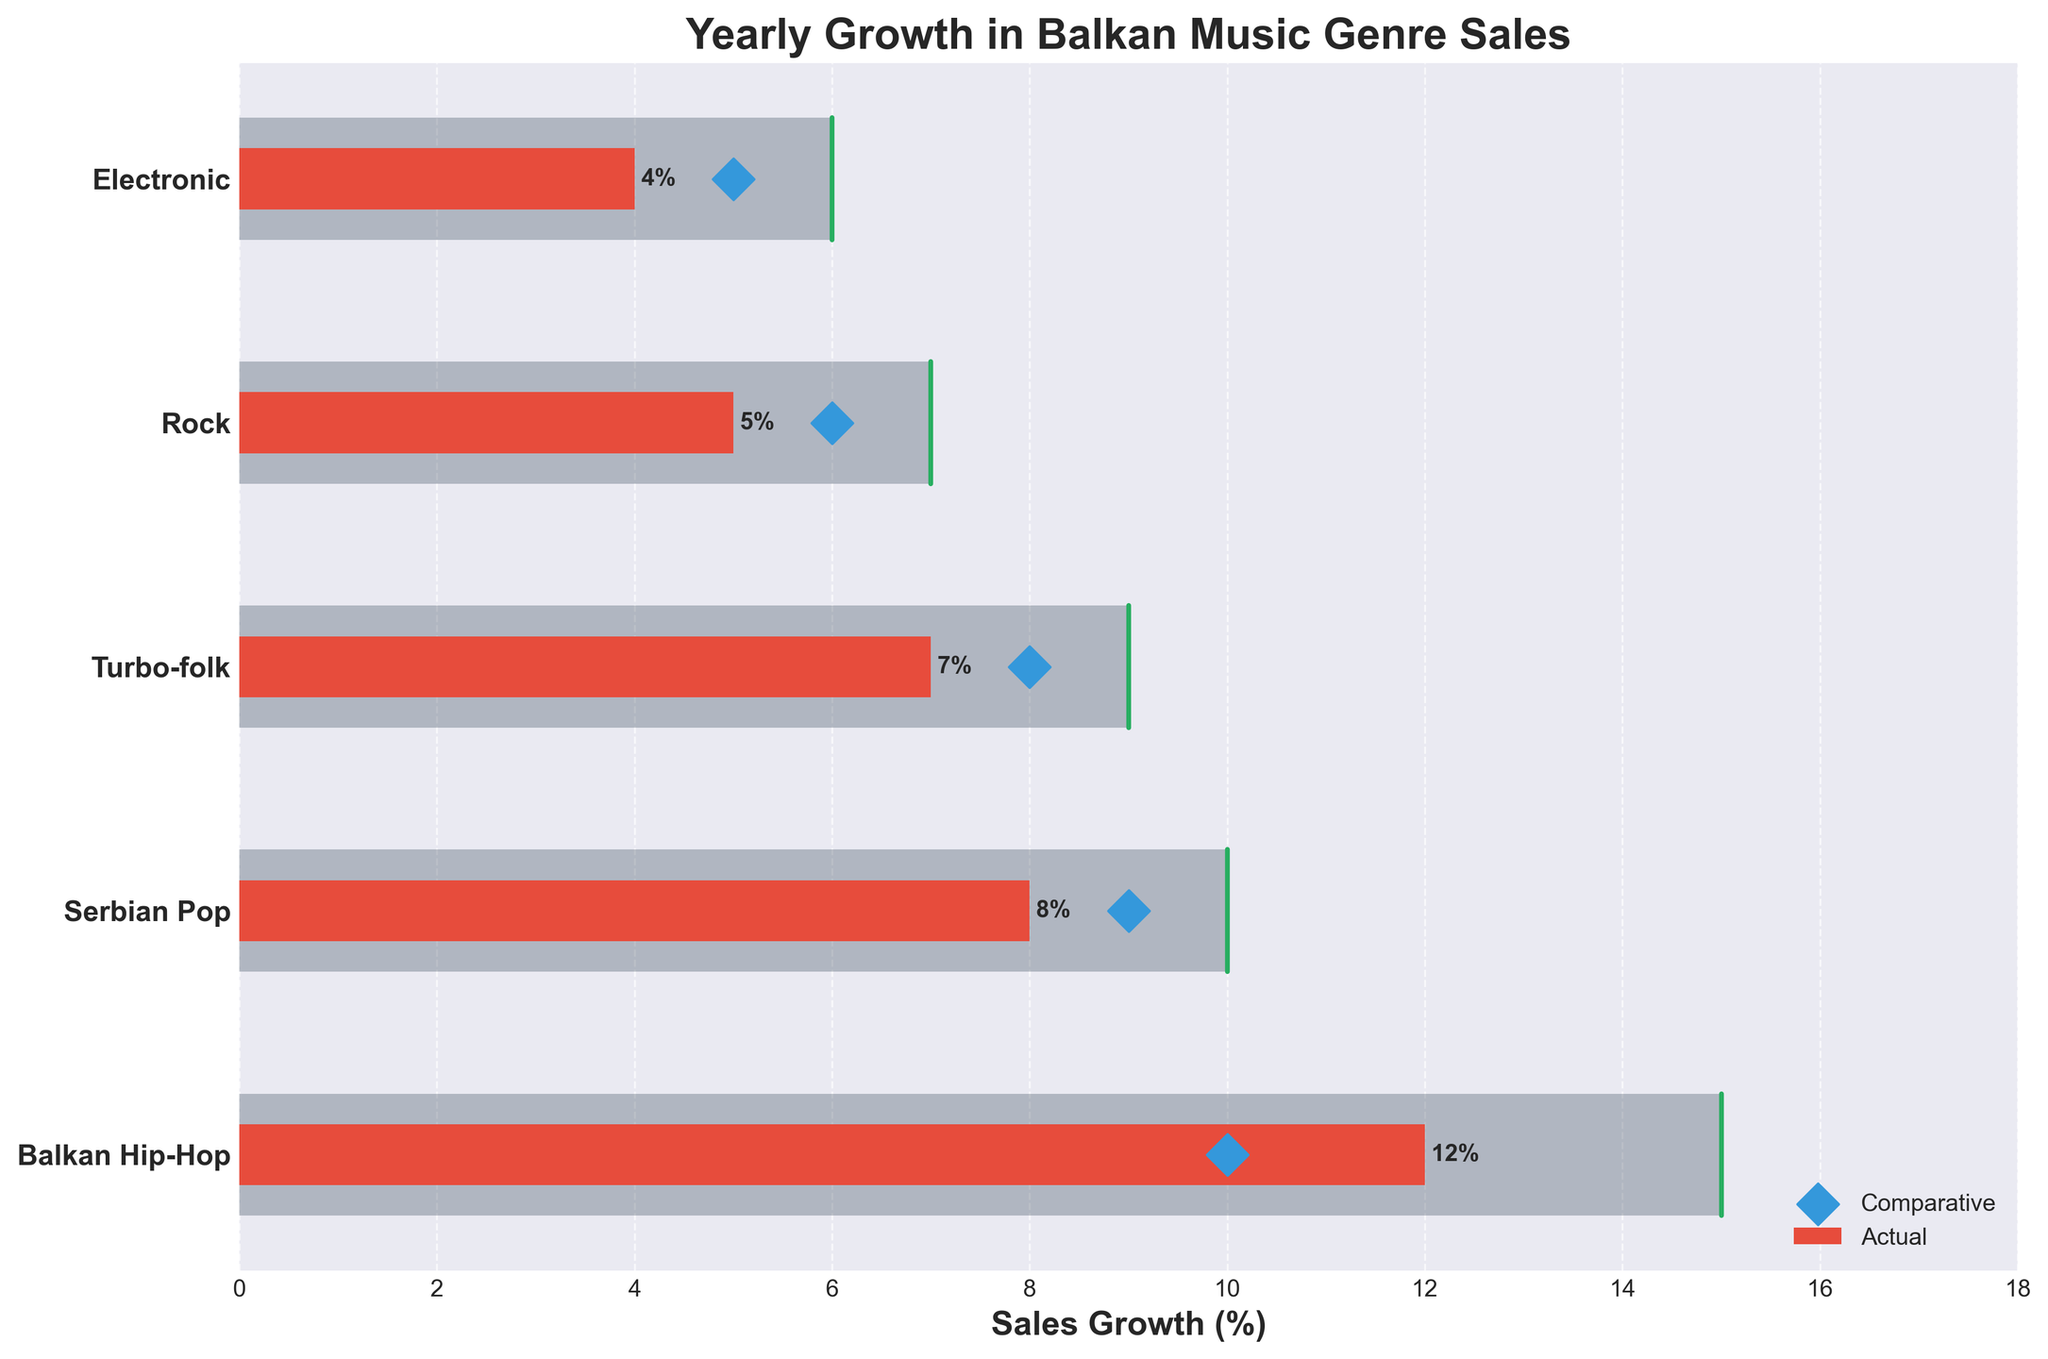What is the title of the figure? The title of the figure is displayed at the top in bold, stating the purpose of the chart.
Answer: Yearly Growth in Balkan Music Genre Sales How many music genres are shown in the figure? By counting the distinct labels on the y-axis, we can see the number of music genres presented in the chart.
Answer: 5 What color represents the actual sales growth of genres? The chart uses a specific color to indicate actual sales growth. This can be identified in the legend or by looking at the sales growth bars.
Answer: Red Which genre has the highest actual yearly sales growth? By comparing the lengths of the red bars, we find that the longest bar indicates the highest actual growth.
Answer: Balkan Hip-Hop How does the actual sales growth of Serbian Pop compare to Turbo-folk? To determine this, we compare the lengths of the red bars for both Serbian Pop and Turbo-folk.
Answer: Greater What are the target values for all genres combined? To find the sum, we add up the target sales growth percentages for each genre listed. Calculation: 15 (Balkan Hip-Hop) + 10 (Serbian Pop) + 9 (Turbo-folk) + 7 (Rock) + 6 (Electronic).
Answer: 47% Which genre has the smallest difference between actual and target sales growth? Identify the difference by subtracting actual from target for each genre and find the smallest value. Balkan Hip-Hop: 15-12=3, Serbian Pop: 10-8=2, Turbo-folk: 9-7=2, Rock: 7-5=2, Electronic: 6-4=2.
Answer: Serbian Pop Is the actual sales growth of Electronic above or below the comparative value? Locate the red bar for Electronic and compare its length to the position of the diamond marker for the comparative value.
Answer: Below What is the average comparative value of all the genres? Add up the comparative values and divide by the number of genres. Calculation: (10 + 9 + 8 + 6 + 5) / 5.
Answer: 7.6 For which genre is the actual growth closest to the comparative value? Calculate the absolute difference between the actual and comparative values for each genre and find the smallest value. Balkan Hip-Hop: 2, Serbian Pop: 1, Turbo-folk: 1, Rock: 1, Electronic: 1.
Answer: Serbian Pop, Turbo-folk, Rock, Electronic 